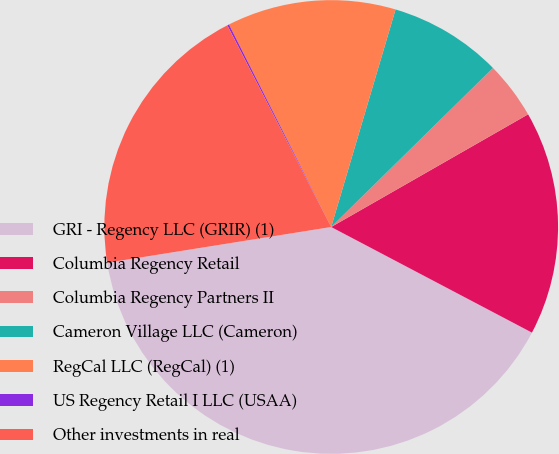Convert chart. <chart><loc_0><loc_0><loc_500><loc_500><pie_chart><fcel>GRI - Regency LLC (GRIR) (1)<fcel>Columbia Regency Retail<fcel>Columbia Regency Partners II<fcel>Cameron Village LLC (Cameron)<fcel>RegCal LLC (RegCal) (1)<fcel>US Regency Retail I LLC (USAA)<fcel>Other investments in real<nl><fcel>39.77%<fcel>15.98%<fcel>4.09%<fcel>8.06%<fcel>12.02%<fcel>0.13%<fcel>19.95%<nl></chart> 